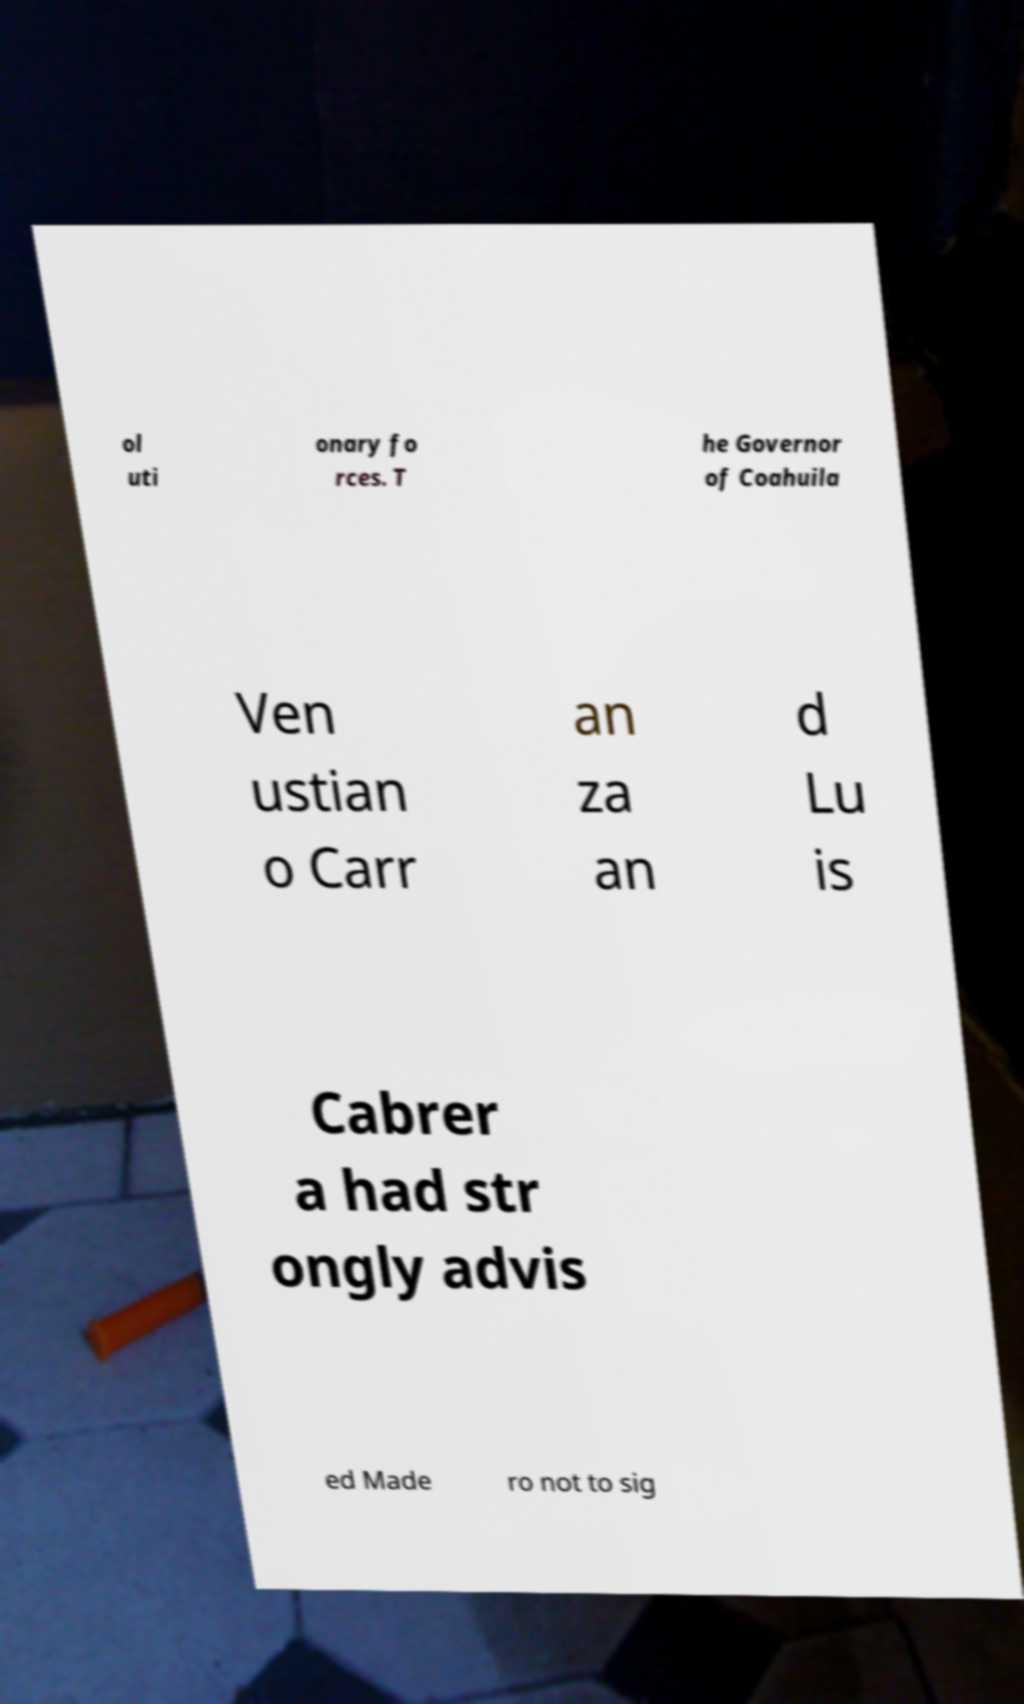Please read and relay the text visible in this image. What does it say? ol uti onary fo rces. T he Governor of Coahuila Ven ustian o Carr an za an d Lu is Cabrer a had str ongly advis ed Made ro not to sig 